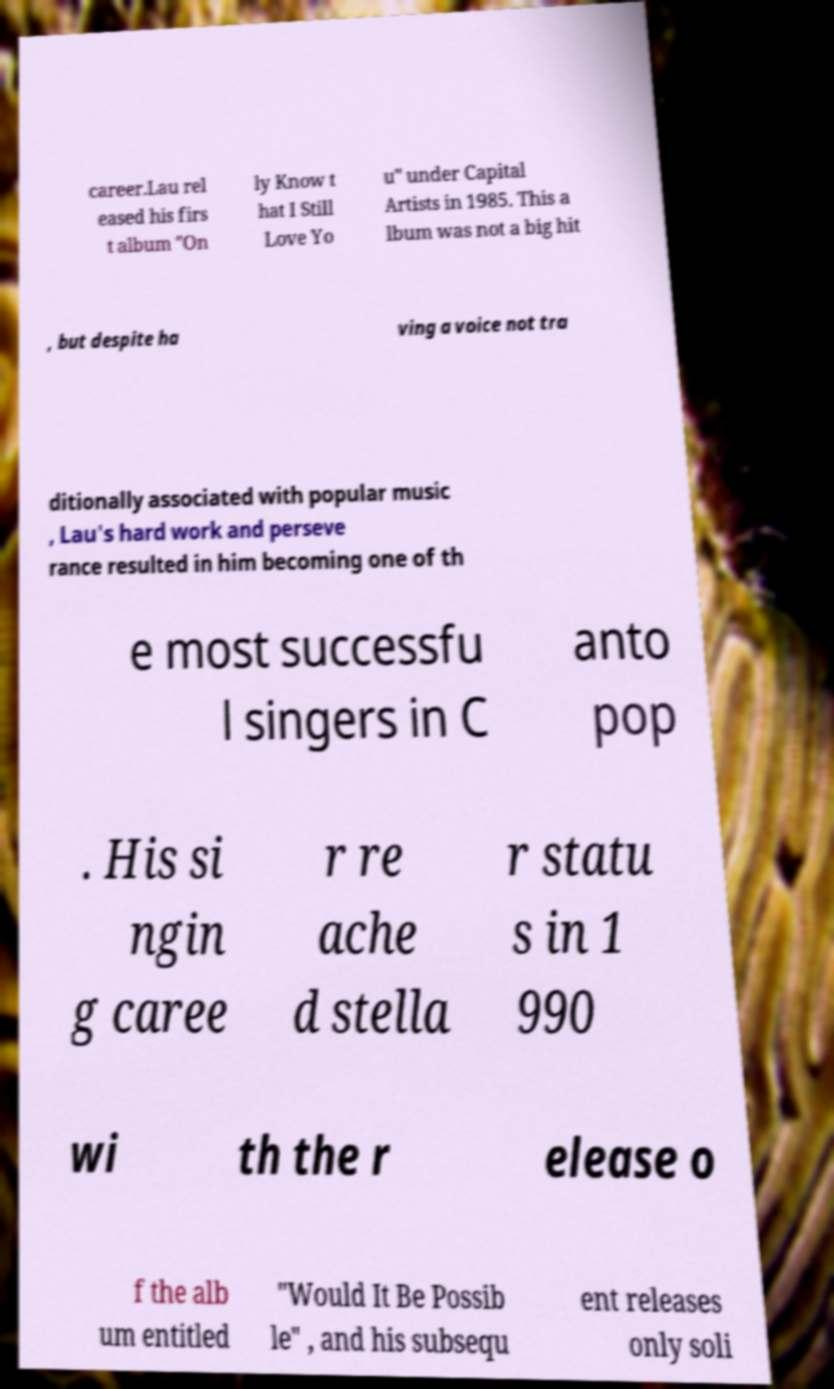There's text embedded in this image that I need extracted. Can you transcribe it verbatim? career.Lau rel eased his firs t album "On ly Know t hat I Still Love Yo u" under Capital Artists in 1985. This a lbum was not a big hit , but despite ha ving a voice not tra ditionally associated with popular music , Lau's hard work and perseve rance resulted in him becoming one of th e most successfu l singers in C anto pop . His si ngin g caree r re ache d stella r statu s in 1 990 wi th the r elease o f the alb um entitled "Would It Be Possib le" , and his subsequ ent releases only soli 